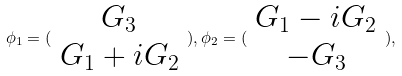Convert formula to latex. <formula><loc_0><loc_0><loc_500><loc_500>\phi _ { 1 } = ( \begin{array} { c } G _ { 3 } \\ G _ { 1 } + i G _ { 2 } \end{array} ) , \phi _ { 2 } = ( \begin{array} { c } G _ { 1 } - i G _ { 2 } \\ - G _ { 3 } \end{array} ) ,</formula> 